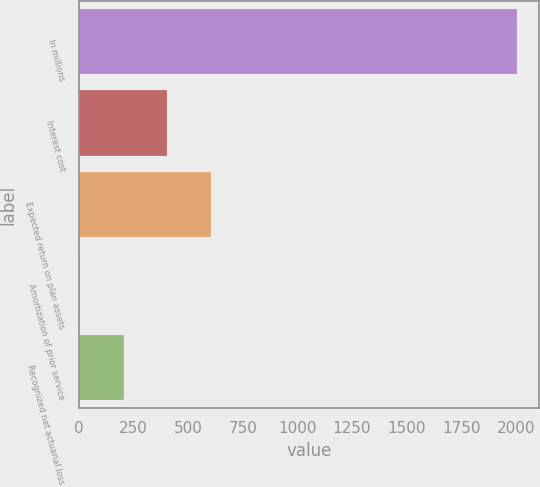Convert chart. <chart><loc_0><loc_0><loc_500><loc_500><bar_chart><fcel>In millions<fcel>Interest cost<fcel>Expected return on plan assets<fcel>Amortization of prior service<fcel>Recognized net actuarial loss<nl><fcel>2008<fcel>404<fcel>604.5<fcel>3<fcel>203.5<nl></chart> 